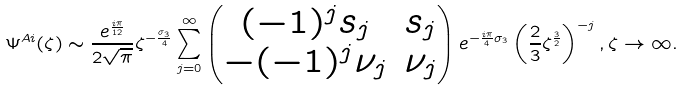Convert formula to latex. <formula><loc_0><loc_0><loc_500><loc_500>\Psi ^ { A i } ( \zeta ) \sim \frac { e ^ { \frac { i \pi } { 1 2 } } } { 2 \sqrt { \pi } } \zeta ^ { - \frac { \sigma _ { 3 } } { 4 } } \sum _ { j = 0 } ^ { \infty } \begin{pmatrix} ( - 1 ) ^ { j } s _ { j } & s _ { j } \\ - ( - 1 ) ^ { j } \nu _ { j } & \nu _ { j } \end{pmatrix} e ^ { - \frac { i \pi } { 4 } \sigma _ { 3 } } \left ( \frac { 2 } { 3 } \zeta ^ { \frac { 3 } { 2 } } \right ) ^ { - j } , \zeta \rightarrow \infty .</formula> 